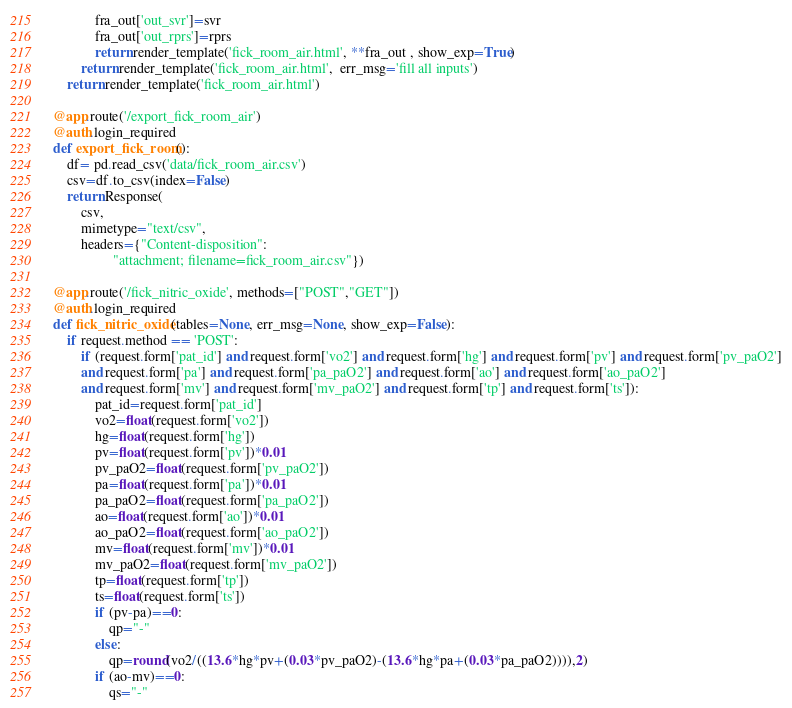<code> <loc_0><loc_0><loc_500><loc_500><_Python_>            fra_out['out_svr']=svr
            fra_out['out_rprs']=rprs
            return render_template('fick_room_air.html', **fra_out , show_exp=True)
        return render_template('fick_room_air.html',  err_msg='fill all inputs')
    return render_template('fick_room_air.html')

@app.route('/export_fick_room_air')
@auth.login_required
def export_fick_room():
    df= pd.read_csv('data/fick_room_air.csv')
    csv=df.to_csv(index=False)
    return Response(
        csv,
        mimetype="text/csv",
        headers={"Content-disposition":
                 "attachment; filename=fick_room_air.csv"})

@app.route('/fick_nitric_oxide', methods=["POST","GET"])
@auth.login_required
def fick_nitric_oxide(tables=None, err_msg=None, show_exp=False):
    if request.method == 'POST':
        if (request.form['pat_id'] and request.form['vo2'] and request.form['hg'] and request.form['pv'] and request.form['pv_paO2']
        and request.form['pa'] and request.form['pa_paO2'] and request.form['ao'] and request.form['ao_paO2']
        and request.form['mv'] and request.form['mv_paO2'] and request.form['tp'] and request.form['ts']):
            pat_id=request.form['pat_id']
            vo2=float(request.form['vo2'])
            hg=float(request.form['hg'])
            pv=float(request.form['pv'])*0.01
            pv_paO2=float(request.form['pv_paO2'])
            pa=float(request.form['pa'])*0.01
            pa_paO2=float(request.form['pa_paO2'])
            ao=float(request.form['ao'])*0.01
            ao_paO2=float(request.form['ao_paO2'])
            mv=float(request.form['mv'])*0.01
            mv_paO2=float(request.form['mv_paO2'])
            tp=float(request.form['tp'])
            ts=float(request.form['ts'])
            if (pv-pa)==0:
                qp="-"
            else: 
                qp=round(vo2/((13.6*hg*pv+(0.03*pv_paO2)-(13.6*hg*pa+(0.03*pa_paO2)))),2)
            if (ao-mv)==0:
                qs="-"</code> 